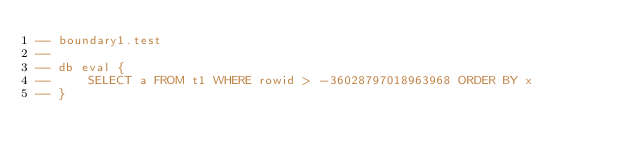<code> <loc_0><loc_0><loc_500><loc_500><_SQL_>-- boundary1.test
-- 
-- db eval {
--     SELECT a FROM t1 WHERE rowid > -36028797018963968 ORDER BY x
-- }</code> 